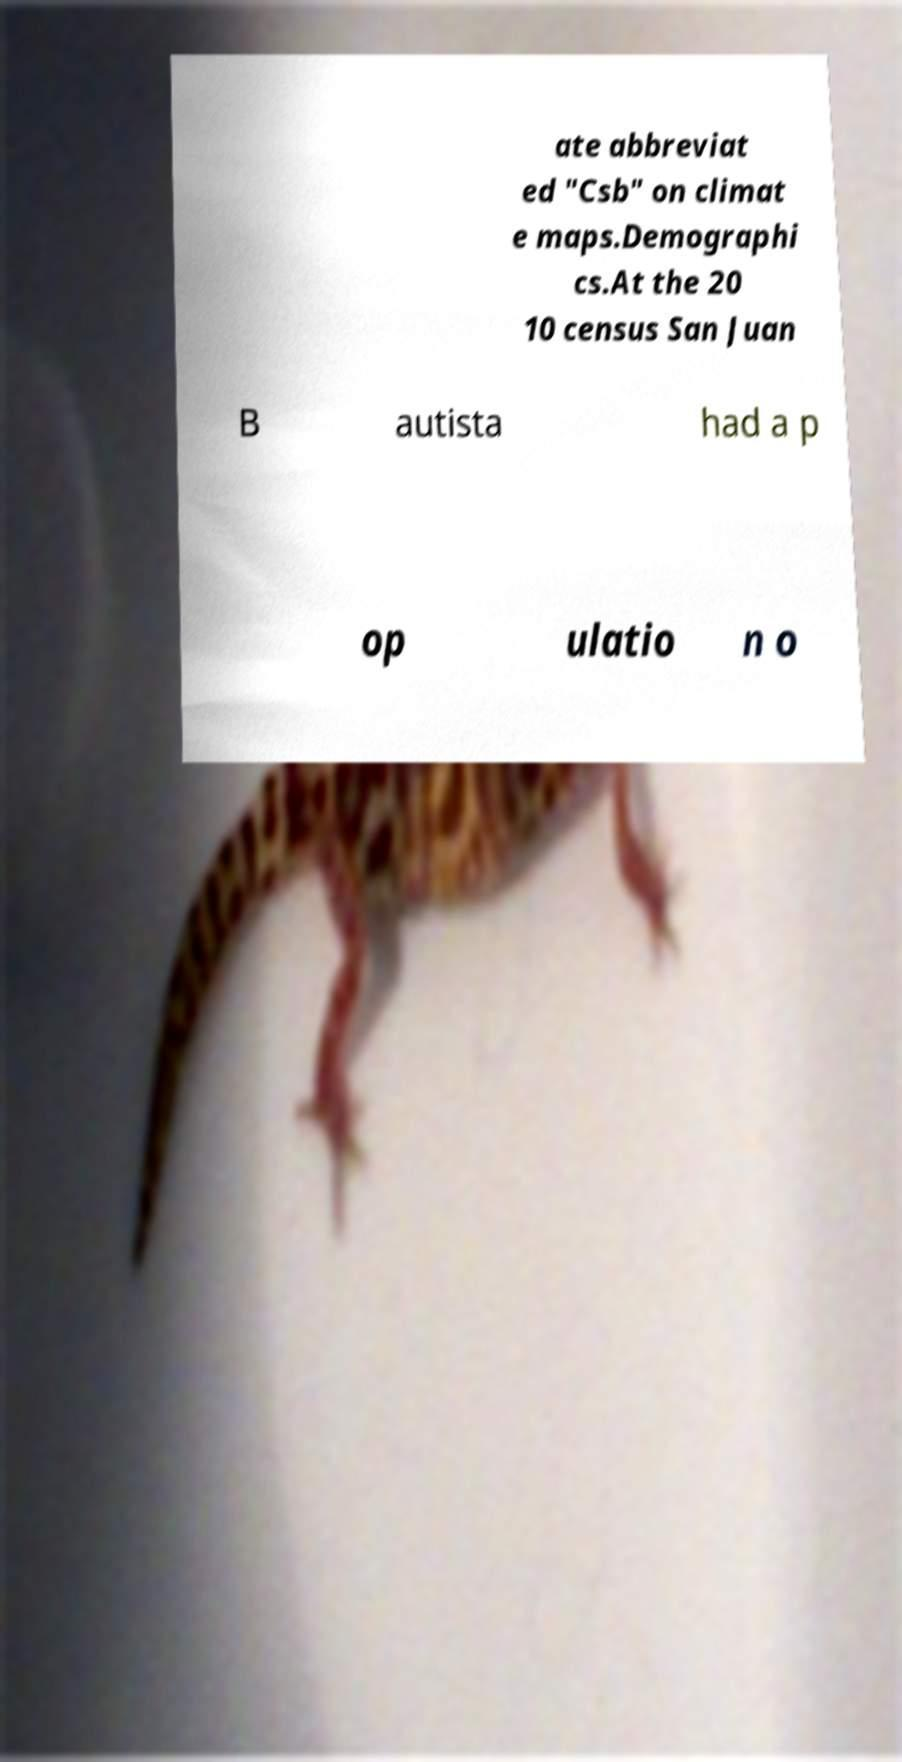There's text embedded in this image that I need extracted. Can you transcribe it verbatim? ate abbreviat ed "Csb" on climat e maps.Demographi cs.At the 20 10 census San Juan B autista had a p op ulatio n o 